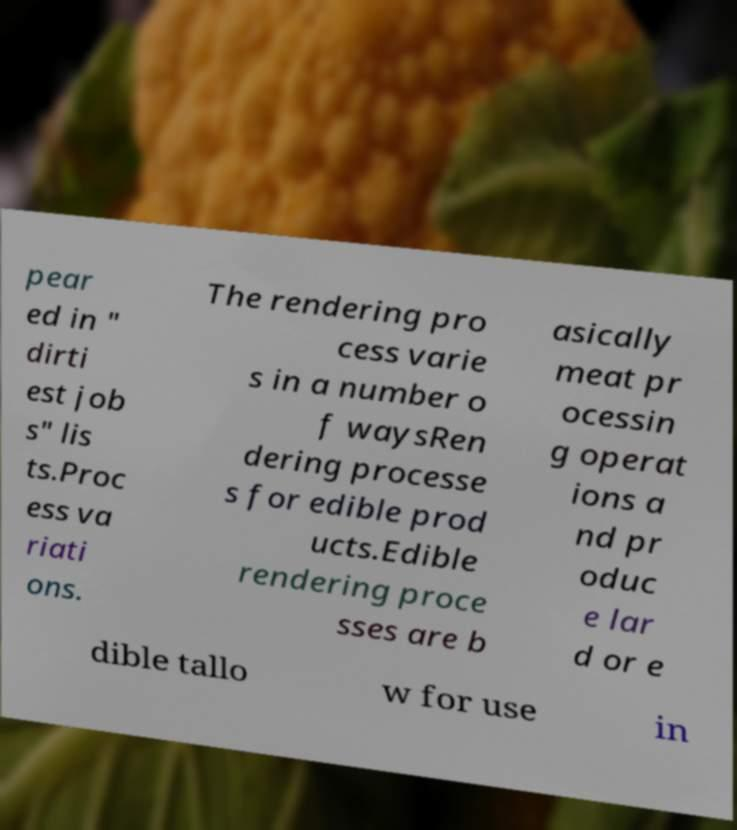Could you extract and type out the text from this image? pear ed in " dirti est job s" lis ts.Proc ess va riati ons. The rendering pro cess varie s in a number o f waysRen dering processe s for edible prod ucts.Edible rendering proce sses are b asically meat pr ocessin g operat ions a nd pr oduc e lar d or e dible tallo w for use in 